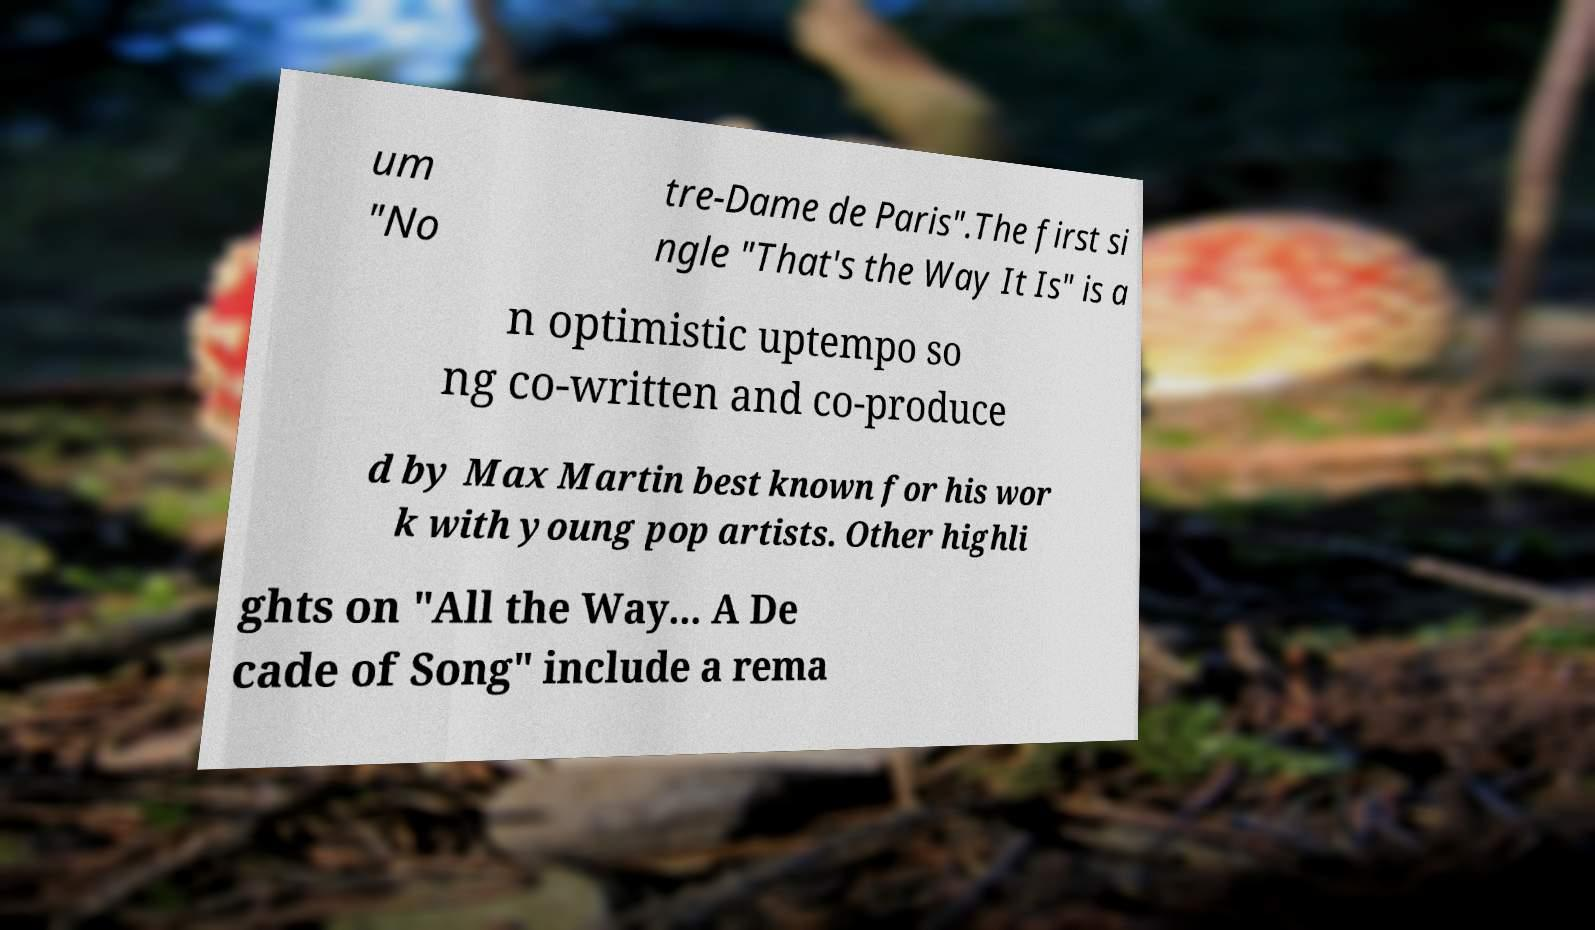For documentation purposes, I need the text within this image transcribed. Could you provide that? um "No tre-Dame de Paris".The first si ngle "That's the Way It Is" is a n optimistic uptempo so ng co-written and co-produce d by Max Martin best known for his wor k with young pop artists. Other highli ghts on "All the Way... A De cade of Song" include a rema 